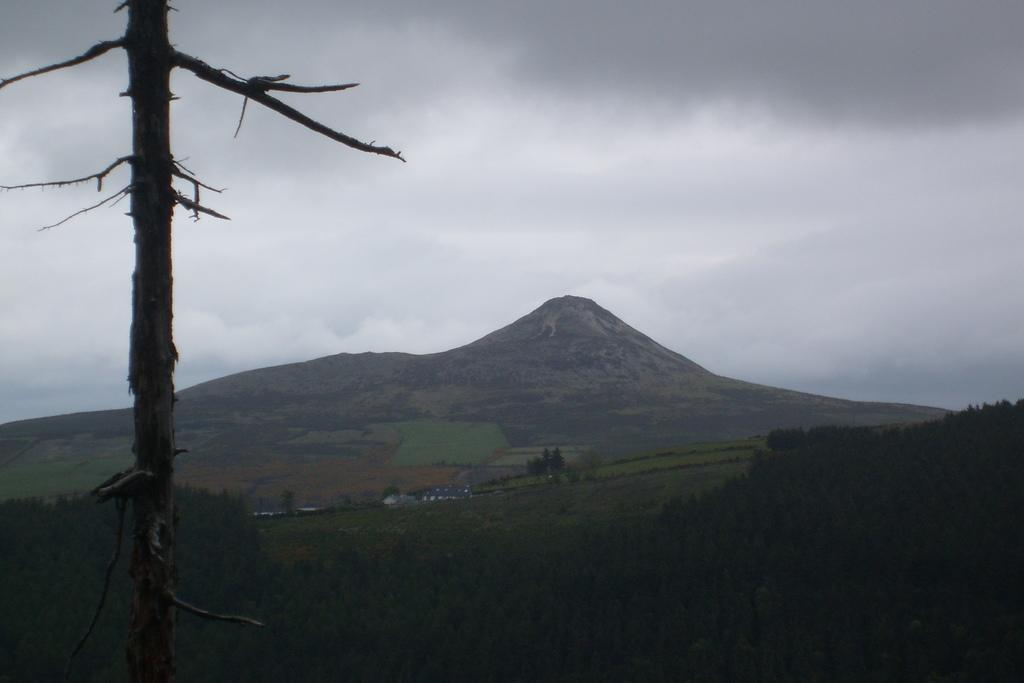What type of landscape feature is present in the image? There is a hill in the image. What type of vegetation can be seen in the image? There are trees in the image. Can you describe the texture of the trees in the image? Tree bark is visible in the image. What is the condition of the sky in the image? The sky is cloudy in the image. What part of the sky is missing from the image? The sky is not missing any part in the image; it is depicted as cloudy. 